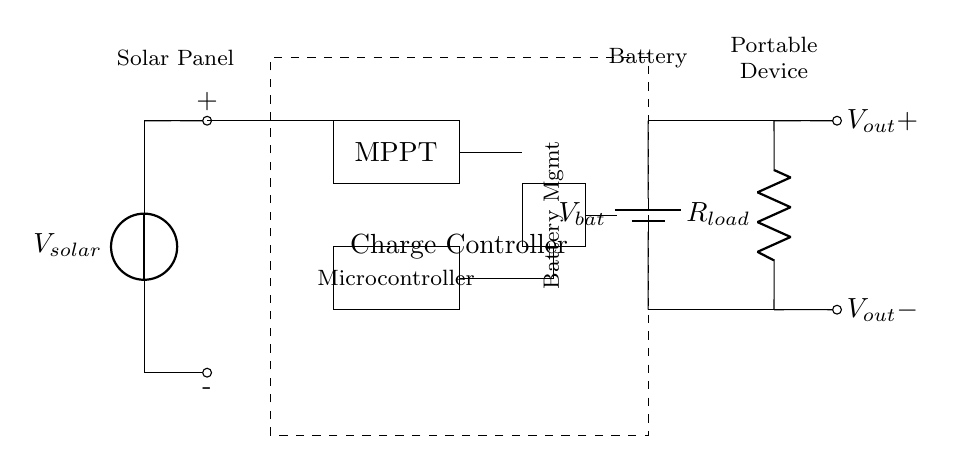What is the primary component generating electricity in this circuit? The primary component generating electricity is the solar panel, which converts solar energy into electrical energy. This is indicated by the label in the circuit diagram.
Answer: solar panel What is the purpose of the MPPT in this circuit? The MPPT (Maximum Power Point Tracking) optimizes the power output from the solar panel. It adjusts the electrical operating point of the solar panels to ensure maximum efficiency in energy harvesting.
Answer: optimize power output What type of load is represented in this circuit? The load represented is a resistor, indicated by the symbol in the diagram. This resistor can represent any electrical component or device that consumes power.
Answer: resistor What is the function of the microcontroller in this setup? The microcontroller controls the operations and functionalities of the charge controller, managing the charging and discharging cycles of the battery and ensuring safe operation.
Answer: control operations How does the battery management system contribute to this circuit? The battery management system ensures the safe charging and discharging of the battery by monitoring its voltage, current, and temperature levels, thus prolonging battery lifespan and preventing damage.
Answer: ensures safe operation What is the output voltage designation in the circuit? The output voltage designation is indicated as V_out+, which represents the positive terminal of the output voltage supplied to the load.
Answer: V_out+ Where does the energy flow from the solar panel to the battery? Energy flows from the solar panel through the charge controller to the battery, where it is stored for later use. This flow is represented by the connections shown in the circuit diagram.
Answer: to the battery 